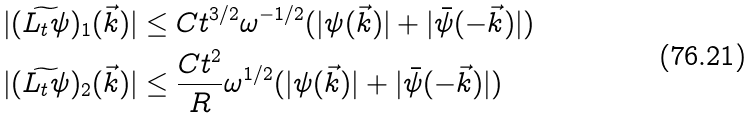<formula> <loc_0><loc_0><loc_500><loc_500>| ( \widetilde { L _ { t } \psi } ) _ { 1 } ( \vec { k } ) | & \leq C t ^ { 3 / 2 } \omega ^ { - 1 / 2 } ( | \psi ( \vec { k } ) | + | \bar { \psi } ( - \vec { k } ) | ) \\ | ( \widetilde { L _ { t } \psi } ) _ { 2 } ( \vec { k } ) | & \leq \frac { C t ^ { 2 } } { R } \omega ^ { 1 / 2 } ( | \psi ( \vec { k } ) | + | \bar { \psi } ( - \vec { k } ) | )</formula> 